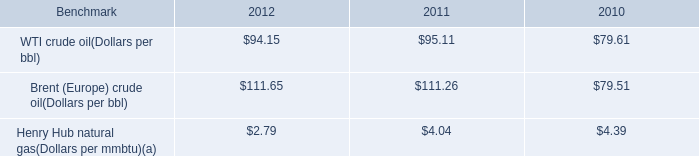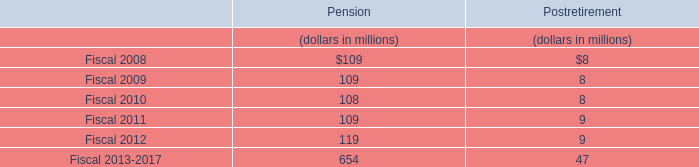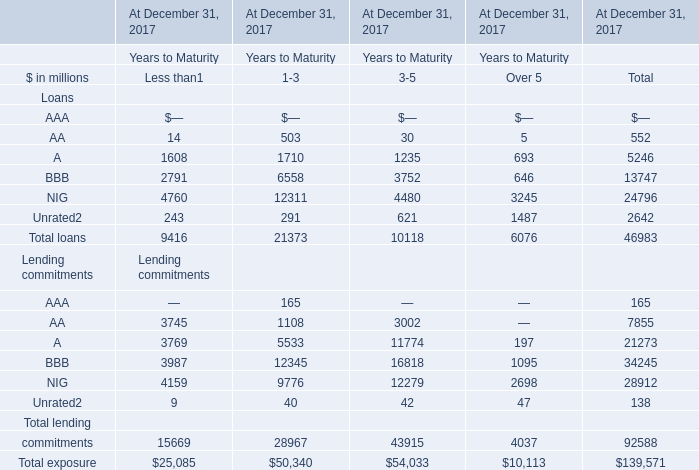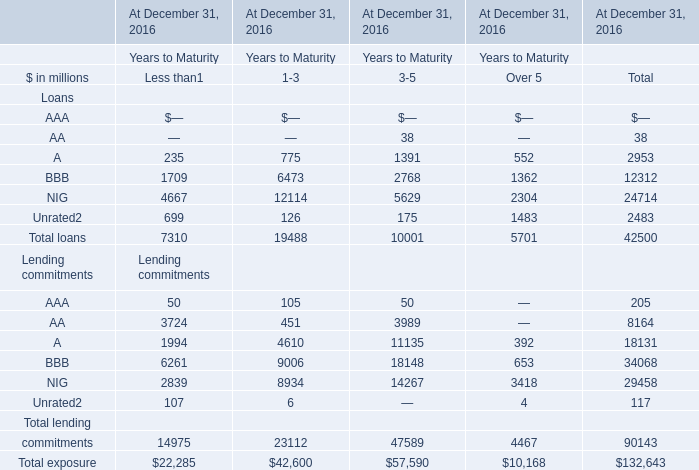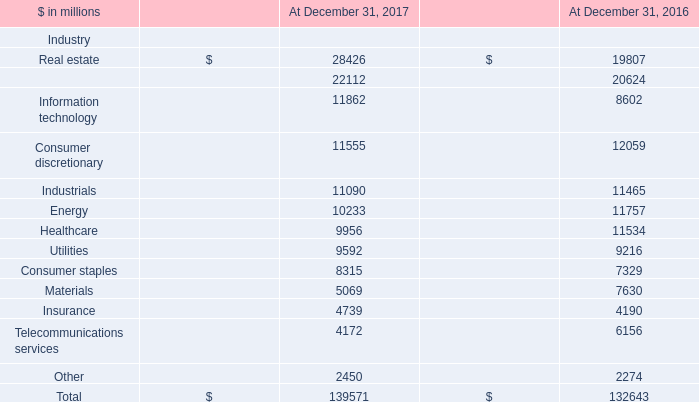What is the growing rate of energy in the year with the most Utilities? (in %) 
Computations: ((10233 - 11757) / 11757)
Answer: -0.12962. 